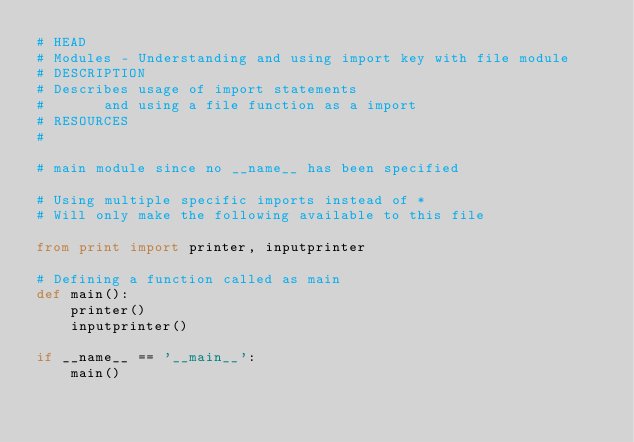<code> <loc_0><loc_0><loc_500><loc_500><_Python_># HEAD
# Modules - Understanding and using import key with file module
# DESCRIPTION
# Describes usage of import statements 
#       and using a file function as a import
# RESOURCES
# 

# main module since no __name__ has been specified

# Using multiple specific imports instead of *
# Will only make the following available to this file

from print import printer, inputprinter

# Defining a function called as main
def main():
    printer()
    inputprinter()

if __name__ == '__main__':
    main()
</code> 